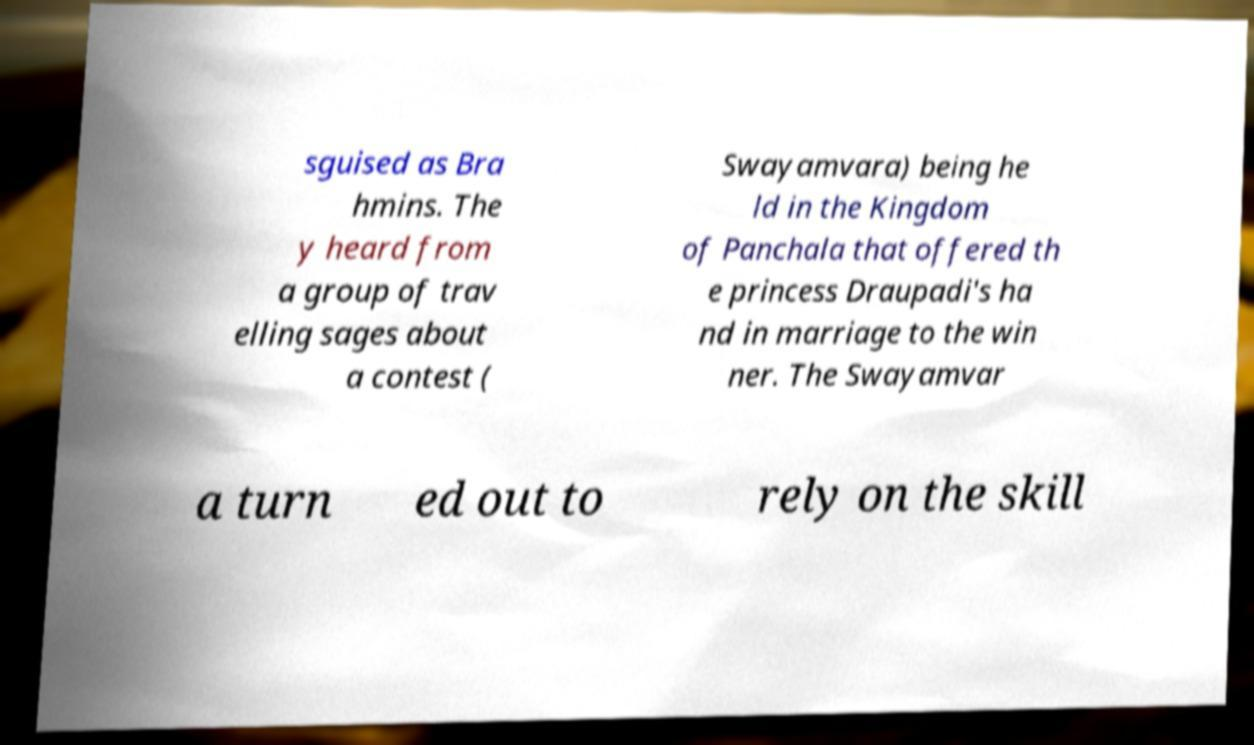There's text embedded in this image that I need extracted. Can you transcribe it verbatim? sguised as Bra hmins. The y heard from a group of trav elling sages about a contest ( Swayamvara) being he ld in the Kingdom of Panchala that offered th e princess Draupadi's ha nd in marriage to the win ner. The Swayamvar a turn ed out to rely on the skill 